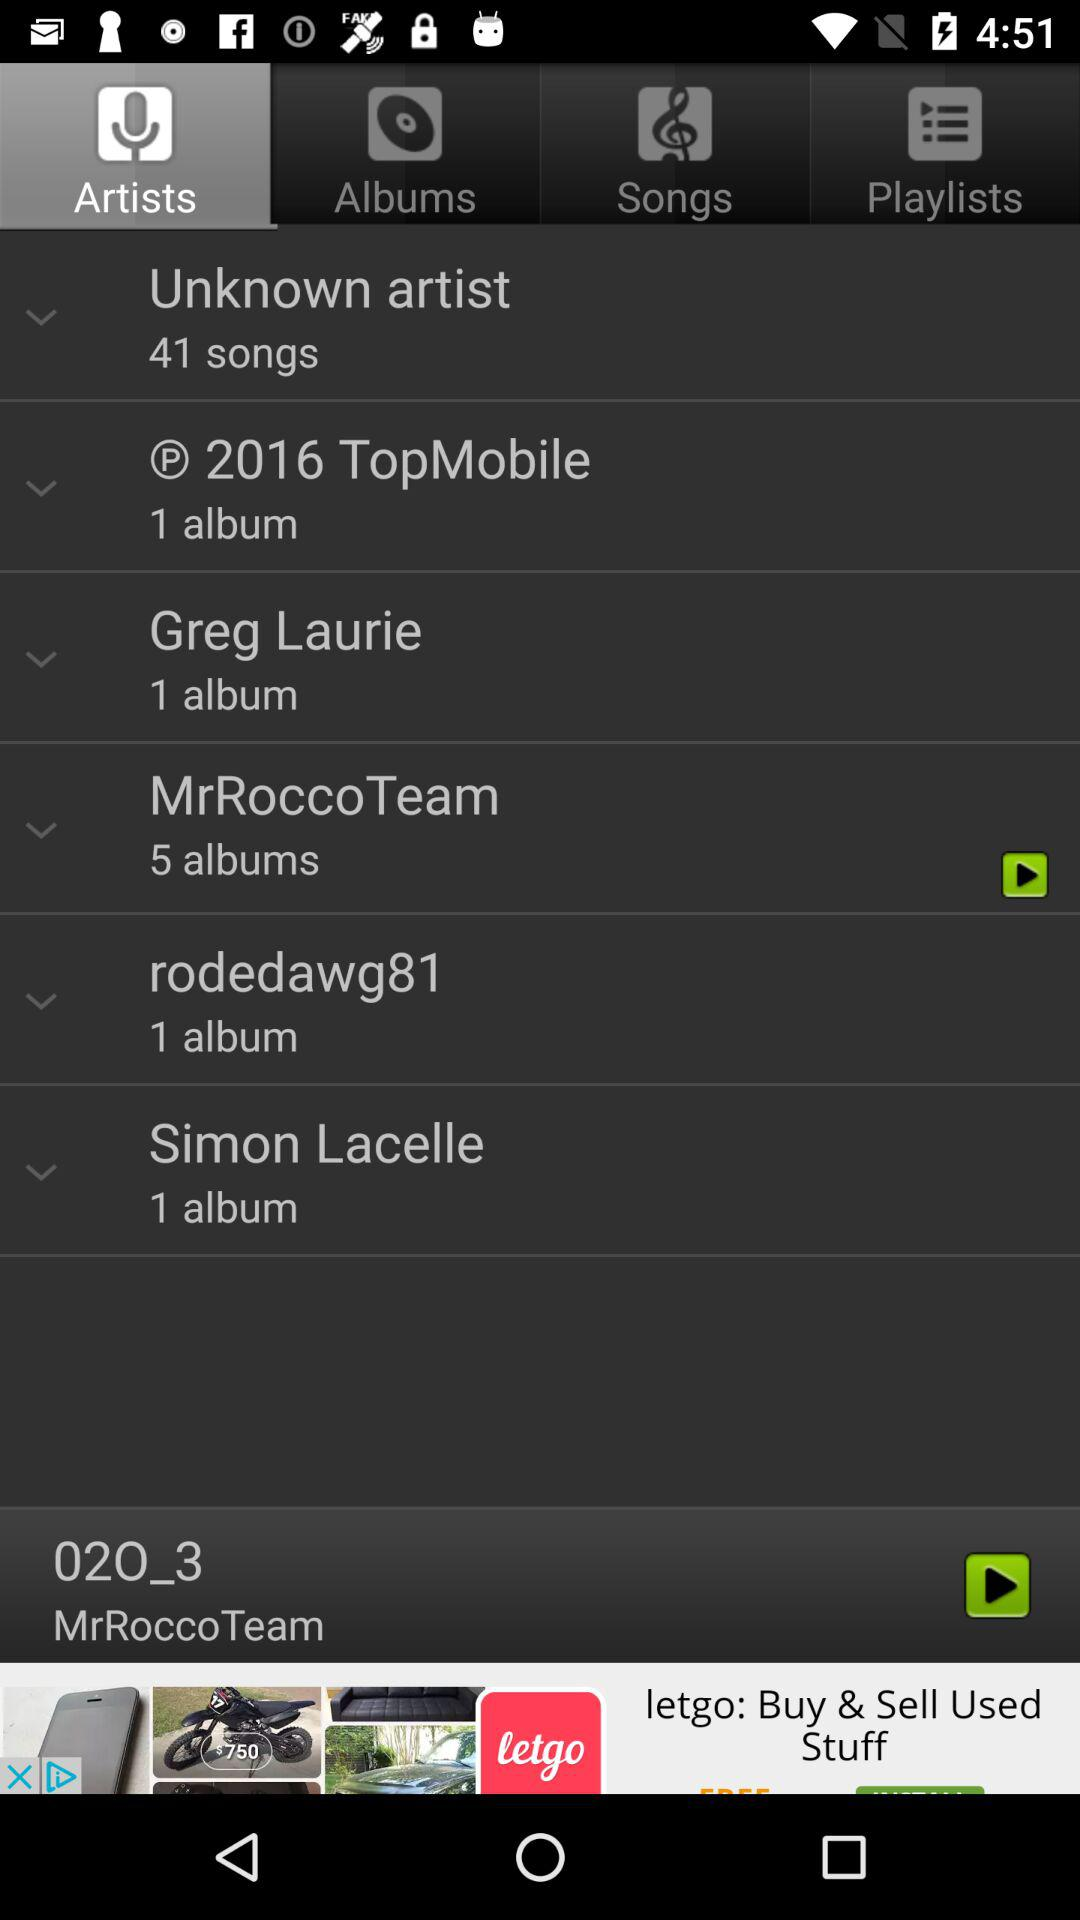Which artist's song was last played? The artist group is "MrRoccoTeam". 